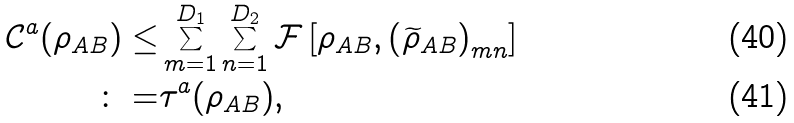<formula> <loc_0><loc_0><loc_500><loc_500>\mathcal { C } ^ { a } ( \rho _ { A B } ) \leq & \sum _ { m = 1 } ^ { D _ { 1 } } \sum _ { n = 1 } ^ { D _ { 2 } } \mathcal { F } \left [ \rho _ { A B } , \left ( \widetilde { \rho } _ { A B } \right ) _ { m n } \right ] \\ \colon = & \tau ^ { a } ( \rho _ { A B } ) ,</formula> 